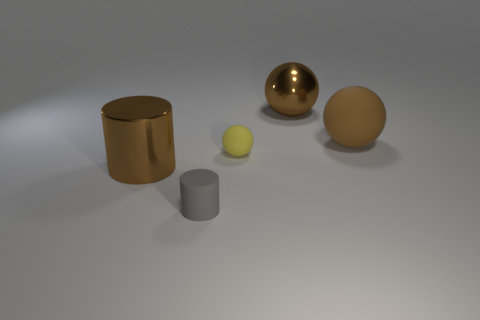The shiny sphere that is right of the small rubber object in front of the big shiny cylinder that is left of the small yellow thing is what color?
Your answer should be very brief. Brown. Is the yellow thing the same size as the gray matte object?
Offer a very short reply. Yes. How many things are large rubber spheres behind the tiny yellow sphere or large brown metal cylinders?
Offer a very short reply. 2. Do the large brown rubber object and the gray rubber object have the same shape?
Your answer should be very brief. No. How many other objects are the same size as the yellow matte sphere?
Your answer should be compact. 1. What color is the small matte ball?
Offer a very short reply. Yellow. What number of small things are blue matte cylinders or gray cylinders?
Make the answer very short. 1. Do the ball that is behind the big rubber object and the matte object that is in front of the tiny yellow matte object have the same size?
Give a very brief answer. No. What size is the metal thing that is the same shape as the tiny yellow matte thing?
Provide a short and direct response. Large. Are there more large objects that are on the right side of the tiny rubber sphere than large brown shiny cylinders that are behind the large brown shiny sphere?
Give a very brief answer. Yes. 